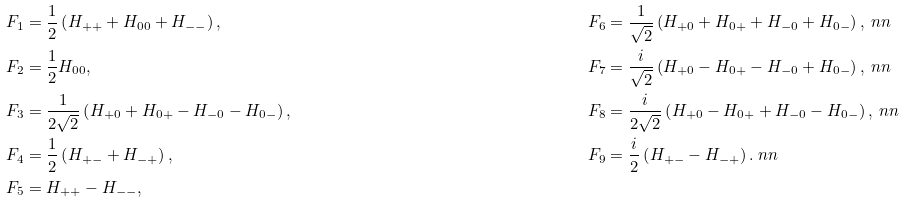Convert formula to latex. <formula><loc_0><loc_0><loc_500><loc_500>& F _ { 1 } = \frac { 1 } { 2 } \left ( H _ { + + } + H _ { 0 0 } + H _ { - - } \right ) , & & F _ { 6 } = \frac { 1 } { \sqrt { 2 } } \left ( H _ { + 0 } + H _ { 0 + } + H _ { - 0 } + H _ { 0 - } \right ) , \ n n \\ & F _ { 2 } = \frac { 1 } { 2 } H _ { 0 0 } , & & F _ { 7 } = \frac { i } { \sqrt { 2 } } \left ( H _ { + 0 } - H _ { 0 + } - H _ { - 0 } + H _ { 0 - } \right ) , \ n n \\ & F _ { 3 } = \frac { 1 } { 2 \sqrt { 2 } } \left ( H _ { + 0 } + H _ { 0 + } - H _ { - 0 } - H _ { 0 - } \right ) , & & F _ { 8 } = \frac { i } { 2 \sqrt { 2 } } \left ( H _ { + 0 } - H _ { 0 + } + H _ { - 0 } - H _ { 0 - } \right ) , \ n n \\ & F _ { 4 } = \frac { 1 } { 2 } \left ( H _ { + - } + H _ { - + } \right ) , & & F _ { 9 } = \frac { i } { 2 } \left ( H _ { + - } - H _ { - + } \right ) . \ n n \\ & F _ { 5 } = H _ { + + } - H _ { - - } ,</formula> 